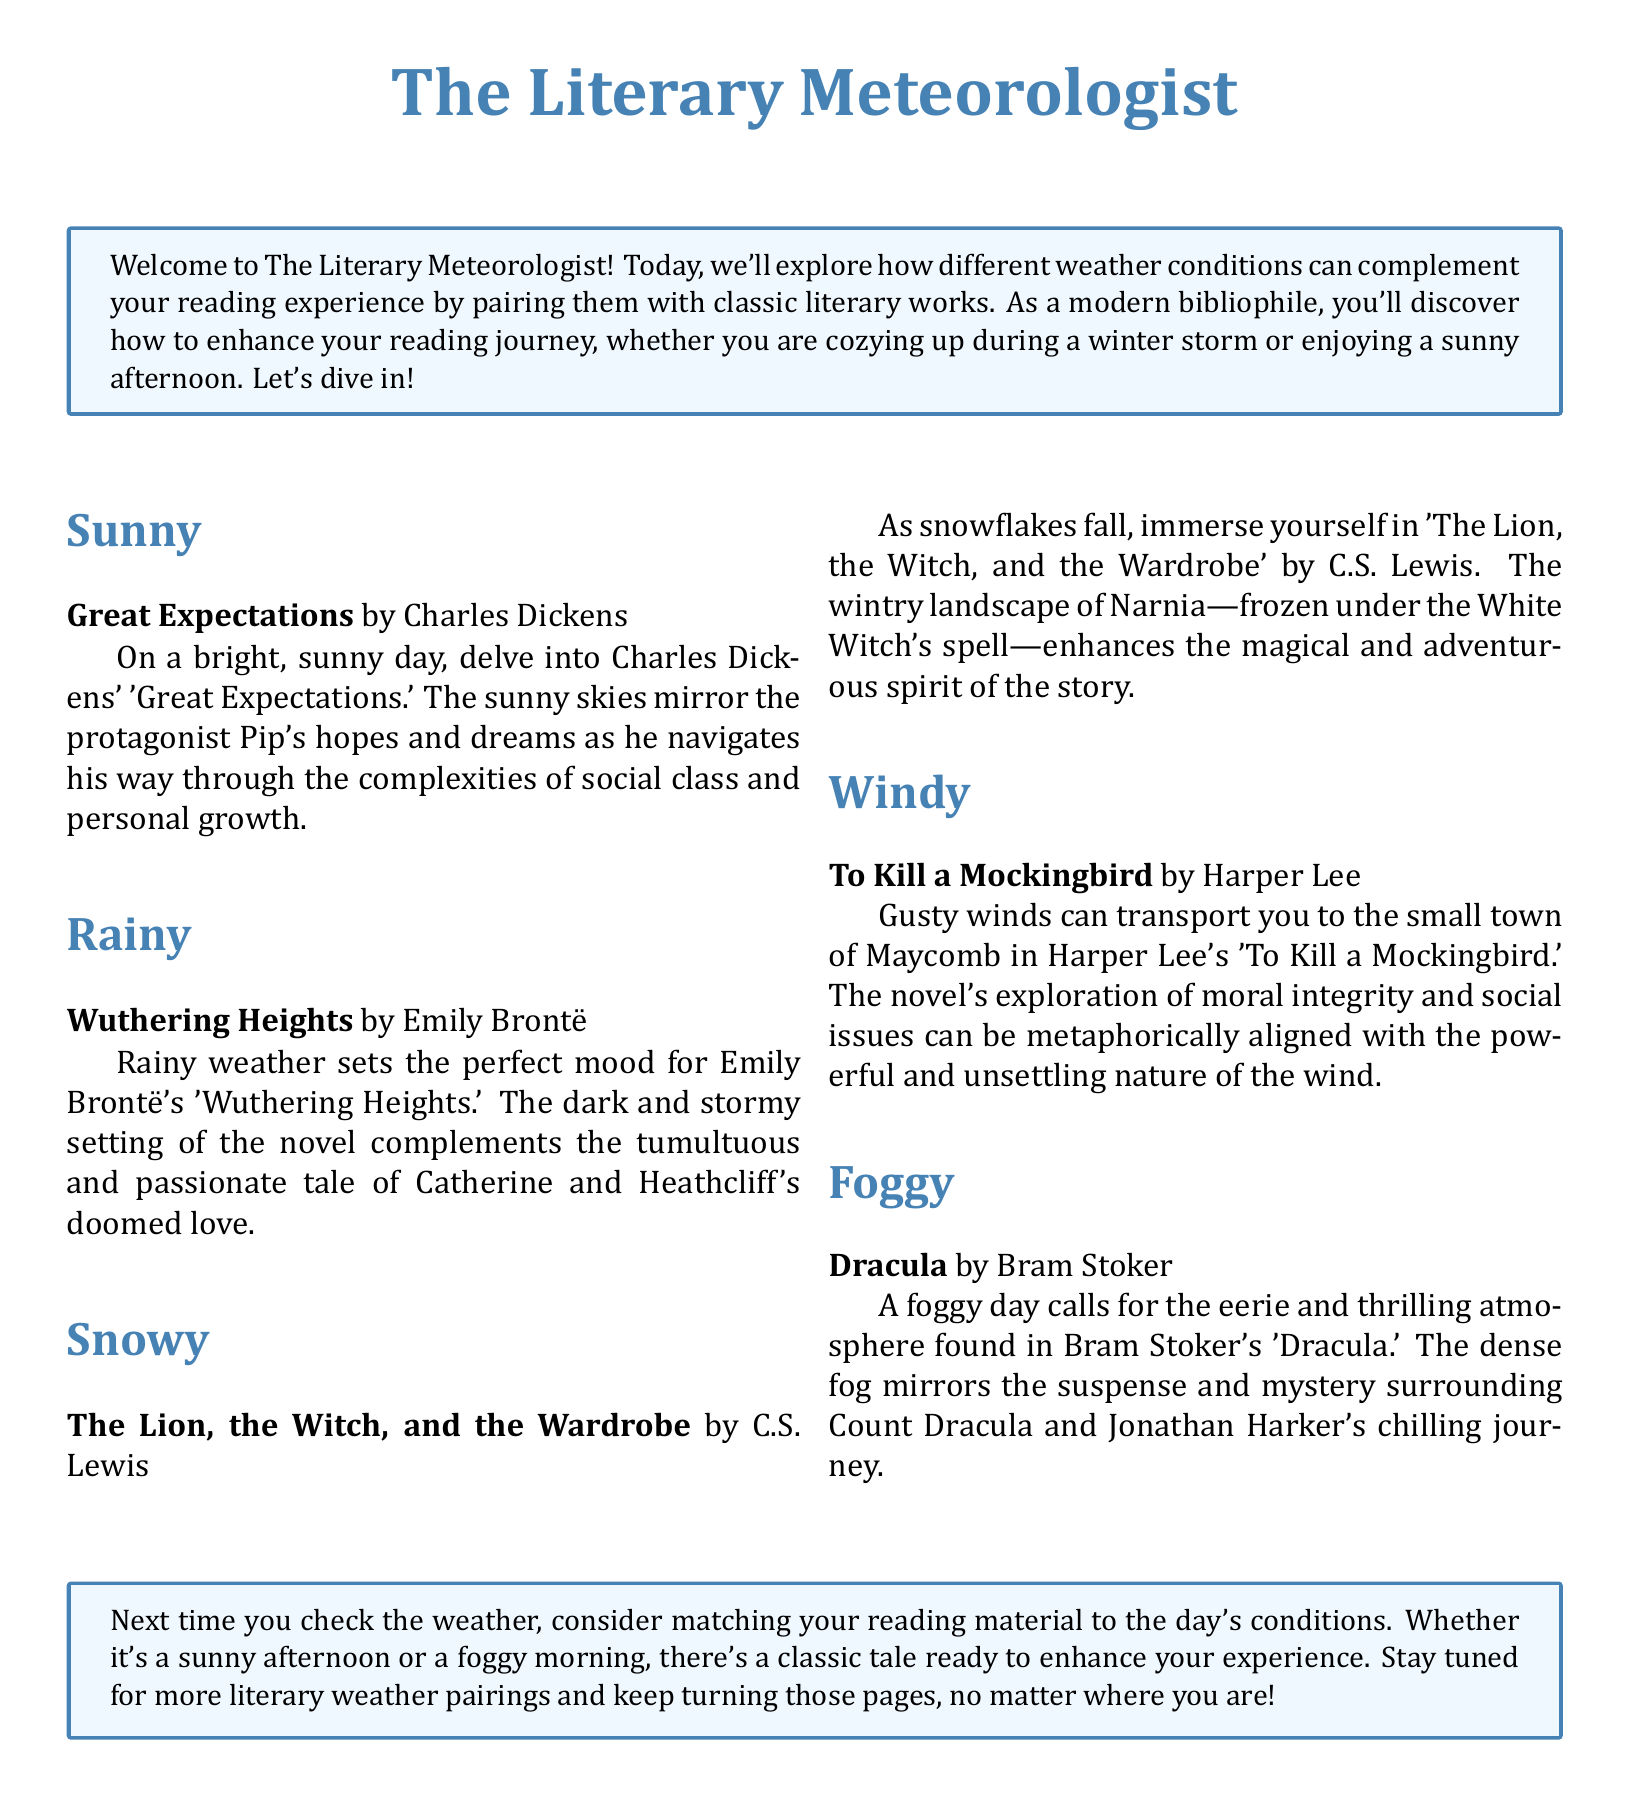What classic novel is suggested for sunny weather? The document states that "Great Expectations" by Charles Dickens is paired with sunny weather.
Answer: Great Expectations Which author wrote "Wuthering Heights"? The document mentions Emily Brontë as the author of "Wuthering Heights."
Answer: Emily Brontë What type of weather complements "Dracula"? The document indicates that a foggy day is suitable for "Dracula."
Answer: Foggy How many literary works are mentioned in total? The document lists a total of five literary works matching different weather conditions.
Answer: Five What is the main theme of "To Kill a Mockingbird"? The document describes the exploration of moral integrity and social issues in "To Kill a Mockingbird."
Answer: Moral integrity and social issues Which weather condition is paired with "The Lion, the Witch, and the Wardrobe"? According to the document, snowy weather enhances the reading experience of "The Lion, the Witch, and the Wardrobe."
Answer: Snowy What do the gusty winds in "To Kill a Mockingbird" represent? The document mentions that the gusty winds metaphorically align with the powerful and unsettling nature of the wind.
Answer: Powerful and unsettling nature What do you enhance by matching reading material to the day's conditions? The document suggests that matching your reading material enhances your experience.
Answer: Your experience 